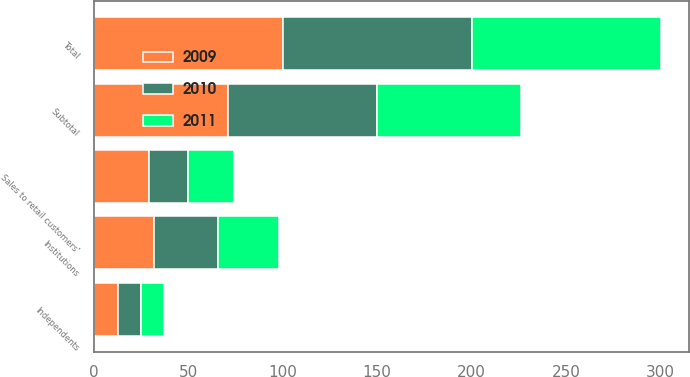Convert chart to OTSL. <chart><loc_0><loc_0><loc_500><loc_500><stacked_bar_chart><ecel><fcel>Independents<fcel>Institutions<fcel>Subtotal<fcel>Sales to retail customers'<fcel>Total<nl><fcel>2010<fcel>12<fcel>34<fcel>79<fcel>21<fcel>100<nl><fcel>2011<fcel>12<fcel>32<fcel>76<fcel>24<fcel>100<nl><fcel>2009<fcel>13<fcel>32<fcel>71<fcel>29<fcel>100<nl></chart> 